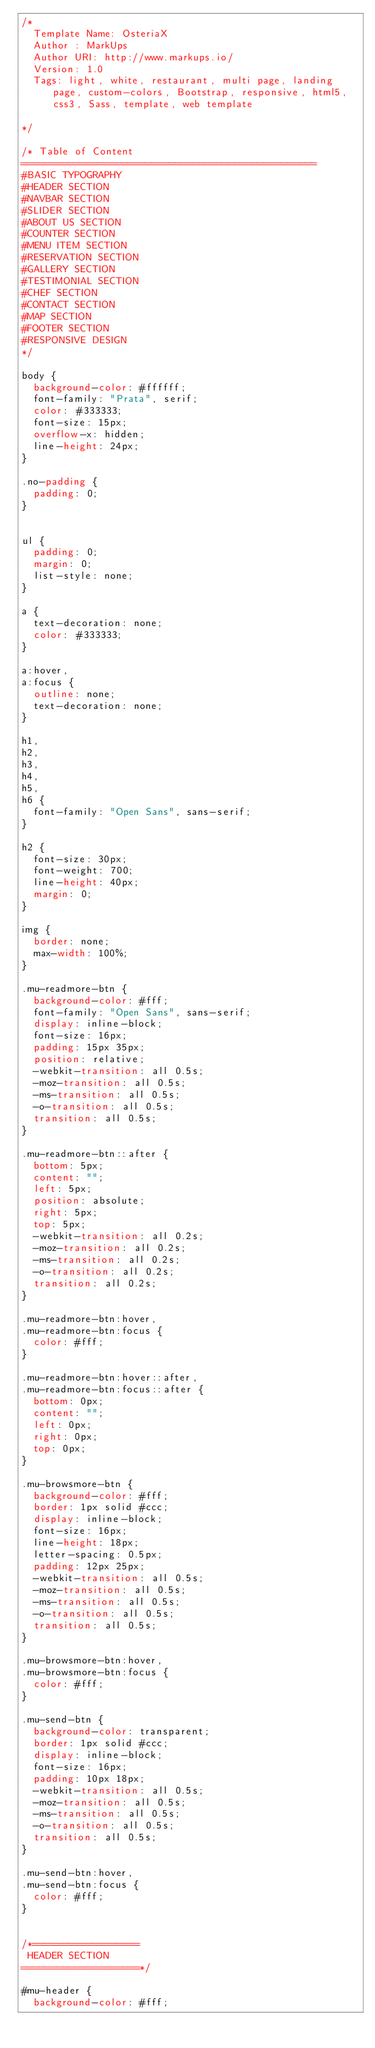<code> <loc_0><loc_0><loc_500><loc_500><_CSS_>/*
  Template Name: OsteriaX
  Author : MarkUps
  Author URI: http://www.markups.io/
  Version: 1.0
  Tags: light, white, restaurant, multi page, landing page, custom-colors, Bootstrap, responsive, html5, css3, Sass, template, web template

*/

/* Table of Content
==================================================
#BASIC TYPOGRAPHY
#HEADER SECTION
#NAVBAR SECTION
#SLIDER SECTION
#ABOUT US SECTION
#COUNTER SECTION
#MENU ITEM SECTION
#RESERVATION SECTION
#GALLERY SECTION
#TESTIMONIAL SECTION
#CHEF SECTION
#CONTACT SECTION
#MAP SECTION
#FOOTER SECTION
#RESPONSIVE DESIGN
*/

body {
  background-color: #ffffff;
  font-family: "Prata", serif;
  color: #333333;
  font-size: 15px;
  overflow-x: hidden;
  line-height: 24px;
}

.no-padding {
  padding: 0;
}


ul {
  padding: 0;
  margin: 0;
  list-style: none;
}

a {
  text-decoration: none;
  color: #333333;
}

a:hover,
a:focus {
  outline: none;
  text-decoration: none;
}

h1, 
h2, 
h3, 
h4, 
h5, 
h6 {
  font-family: "Open Sans", sans-serif;
}

h2 {
  font-size: 30px;
  font-weight: 700;
  line-height: 40px;
  margin: 0;
}

img {
  border: none;
  max-width: 100%;
}

.mu-readmore-btn {
  background-color: #fff;
  font-family: "Open Sans", sans-serif;
  display: inline-block;
  font-size: 16px;
  padding: 15px 35px;
  position: relative;
  -webkit-transition: all 0.5s;
  -moz-transition: all 0.5s;
  -ms-transition: all 0.5s;
  -o-transition: all 0.5s;
  transition: all 0.5s;
}

.mu-readmore-btn::after {
  bottom: 5px;
  content: "";
  left: 5px;
  position: absolute;
  right: 5px;
  top: 5px;
  -webkit-transition: all 0.2s;
  -moz-transition: all 0.2s;
  -ms-transition: all 0.2s;
  -o-transition: all 0.2s;
  transition: all 0.2s;
}

.mu-readmore-btn:hover, 
.mu-readmore-btn:focus {
  color: #fff;
}

.mu-readmore-btn:hover::after, 
.mu-readmore-btn:focus::after {
  bottom: 0px;
  content: "";
  left: 0px;
  right: 0px;
  top: 0px;
}

.mu-browsmore-btn {
  background-color: #fff;
  border: 1px solid #ccc;
  display: inline-block;
  font-size: 16px;
  line-height: 18px;
  letter-spacing: 0.5px;
  padding: 12px 25px;
  -webkit-transition: all 0.5s;
  -moz-transition: all 0.5s;
  -ms-transition: all 0.5s;
  -o-transition: all 0.5s;
  transition: all 0.5s;
}

.mu-browsmore-btn:hover, 
.mu-browsmore-btn:focus {
  color: #fff;
}

.mu-send-btn {
  background-color: transparent;
  border: 1px solid #ccc;
  display: inline-block;
  font-size: 16px;
  padding: 10px 18px;
  -webkit-transition: all 0.5s;
  -moz-transition: all 0.5s;
  -ms-transition: all 0.5s;
  -o-transition: all 0.5s;
  transition: all 0.5s;
}

.mu-send-btn:hover, 
.mu-send-btn:focus {
  color: #fff;
}


/*==================
 HEADER SECTION
====================*/

#mu-header {
  background-color: #fff;</code> 